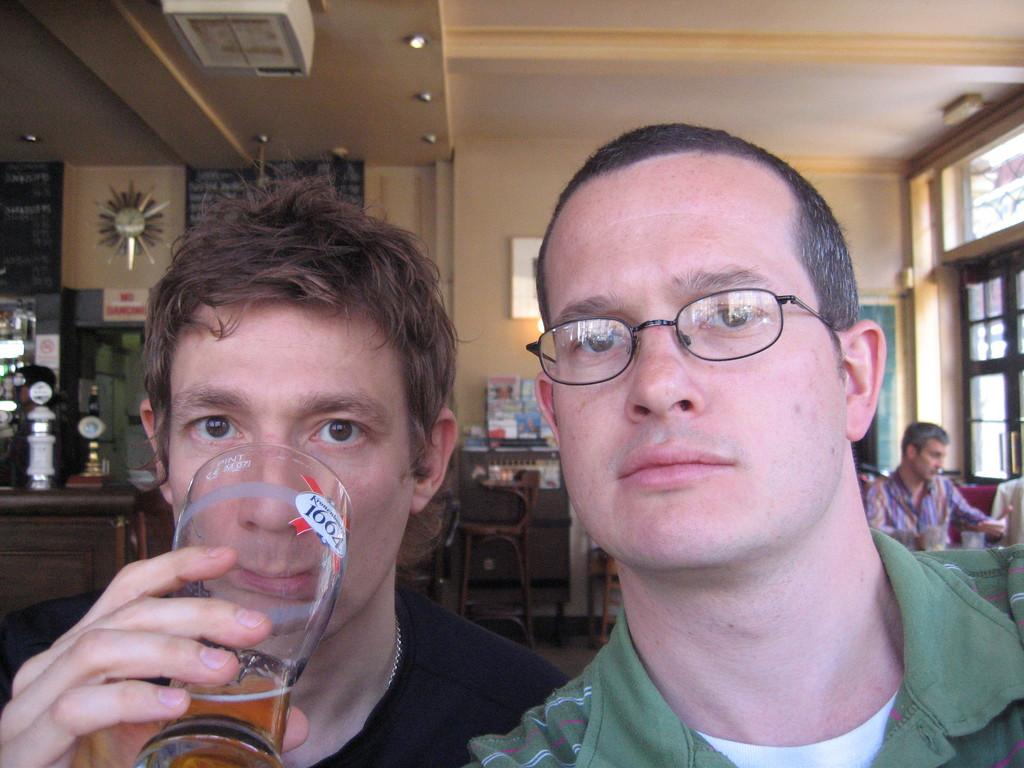How many people are in the image? There are persons in the image, but the exact number is not specified. What is one person holding in the image? One person is holding a glass in the image. What is the position of one person in the image? One person is sitting on a chair in the image. Can you describe the furniture in the image? There are chairs and tables in the image. What can be seen in the background of the image? There is a wall, posters, and framed objects in the background of the image. Are there any ants crawling on the arm of the person sitting on the chair in the image? There is no mention of ants or any person's arm in the image, so it cannot be determined from the provided facts. 